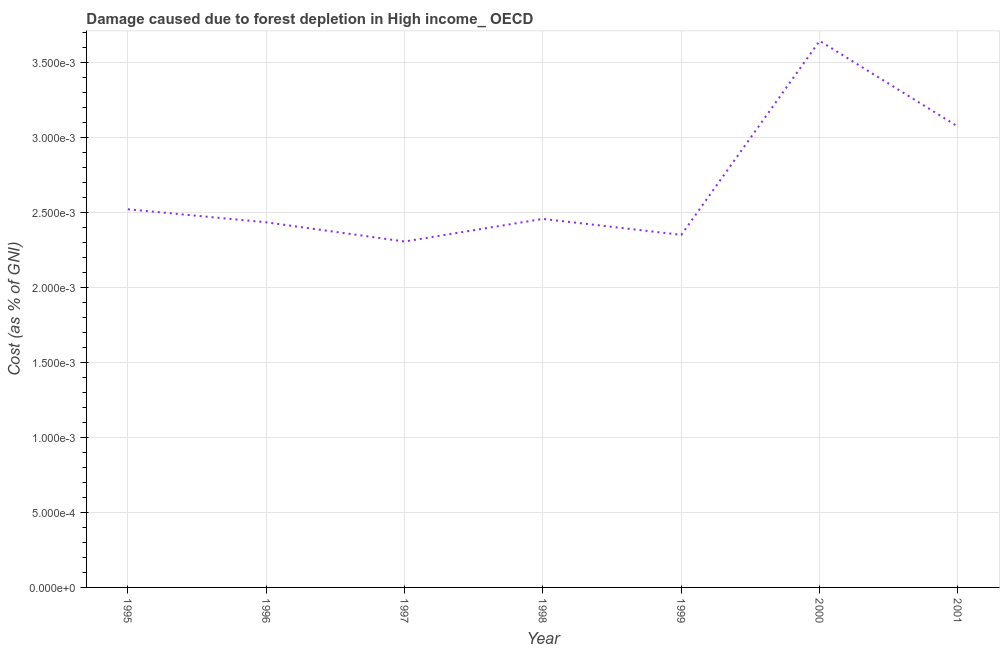What is the damage caused due to forest depletion in 2001?
Keep it short and to the point. 0. Across all years, what is the maximum damage caused due to forest depletion?
Ensure brevity in your answer.  0. Across all years, what is the minimum damage caused due to forest depletion?
Give a very brief answer. 0. In which year was the damage caused due to forest depletion maximum?
Offer a terse response. 2000. In which year was the damage caused due to forest depletion minimum?
Give a very brief answer. 1997. What is the sum of the damage caused due to forest depletion?
Your answer should be compact. 0.02. What is the difference between the damage caused due to forest depletion in 1997 and 1999?
Keep it short and to the point. -4.4440238884519995e-5. What is the average damage caused due to forest depletion per year?
Your answer should be compact. 0. What is the median damage caused due to forest depletion?
Offer a very short reply. 0. What is the ratio of the damage caused due to forest depletion in 1997 to that in 2000?
Ensure brevity in your answer.  0.63. Is the damage caused due to forest depletion in 1999 less than that in 2001?
Provide a short and direct response. Yes. Is the difference between the damage caused due to forest depletion in 1995 and 1997 greater than the difference between any two years?
Provide a short and direct response. No. What is the difference between the highest and the second highest damage caused due to forest depletion?
Your answer should be very brief. 0. Is the sum of the damage caused due to forest depletion in 1996 and 1998 greater than the maximum damage caused due to forest depletion across all years?
Keep it short and to the point. Yes. What is the difference between the highest and the lowest damage caused due to forest depletion?
Your response must be concise. 0. In how many years, is the damage caused due to forest depletion greater than the average damage caused due to forest depletion taken over all years?
Give a very brief answer. 2. What is the difference between two consecutive major ticks on the Y-axis?
Keep it short and to the point. 0. Are the values on the major ticks of Y-axis written in scientific E-notation?
Make the answer very short. Yes. What is the title of the graph?
Give a very brief answer. Damage caused due to forest depletion in High income_ OECD. What is the label or title of the Y-axis?
Your answer should be very brief. Cost (as % of GNI). What is the Cost (as % of GNI) in 1995?
Offer a very short reply. 0. What is the Cost (as % of GNI) in 1996?
Provide a succinct answer. 0. What is the Cost (as % of GNI) of 1997?
Ensure brevity in your answer.  0. What is the Cost (as % of GNI) in 1998?
Your answer should be very brief. 0. What is the Cost (as % of GNI) of 1999?
Make the answer very short. 0. What is the Cost (as % of GNI) of 2000?
Give a very brief answer. 0. What is the Cost (as % of GNI) of 2001?
Provide a succinct answer. 0. What is the difference between the Cost (as % of GNI) in 1995 and 1996?
Your answer should be compact. 9e-5. What is the difference between the Cost (as % of GNI) in 1995 and 1997?
Give a very brief answer. 0. What is the difference between the Cost (as % of GNI) in 1995 and 1998?
Provide a short and direct response. 6e-5. What is the difference between the Cost (as % of GNI) in 1995 and 1999?
Ensure brevity in your answer.  0. What is the difference between the Cost (as % of GNI) in 1995 and 2000?
Your answer should be compact. -0. What is the difference between the Cost (as % of GNI) in 1995 and 2001?
Make the answer very short. -0. What is the difference between the Cost (as % of GNI) in 1996 and 1997?
Make the answer very short. 0. What is the difference between the Cost (as % of GNI) in 1996 and 1998?
Provide a short and direct response. -2e-5. What is the difference between the Cost (as % of GNI) in 1996 and 1999?
Provide a succinct answer. 8e-5. What is the difference between the Cost (as % of GNI) in 1996 and 2000?
Provide a succinct answer. -0. What is the difference between the Cost (as % of GNI) in 1996 and 2001?
Your answer should be compact. -0. What is the difference between the Cost (as % of GNI) in 1997 and 1998?
Provide a succinct answer. -0. What is the difference between the Cost (as % of GNI) in 1997 and 1999?
Your answer should be very brief. -4e-5. What is the difference between the Cost (as % of GNI) in 1997 and 2000?
Offer a terse response. -0. What is the difference between the Cost (as % of GNI) in 1997 and 2001?
Provide a succinct answer. -0. What is the difference between the Cost (as % of GNI) in 1998 and 1999?
Ensure brevity in your answer.  0. What is the difference between the Cost (as % of GNI) in 1998 and 2000?
Offer a very short reply. -0. What is the difference between the Cost (as % of GNI) in 1998 and 2001?
Give a very brief answer. -0. What is the difference between the Cost (as % of GNI) in 1999 and 2000?
Your answer should be very brief. -0. What is the difference between the Cost (as % of GNI) in 1999 and 2001?
Ensure brevity in your answer.  -0. What is the difference between the Cost (as % of GNI) in 2000 and 2001?
Offer a very short reply. 0. What is the ratio of the Cost (as % of GNI) in 1995 to that in 1996?
Offer a very short reply. 1.04. What is the ratio of the Cost (as % of GNI) in 1995 to that in 1997?
Your answer should be very brief. 1.09. What is the ratio of the Cost (as % of GNI) in 1995 to that in 1998?
Give a very brief answer. 1.03. What is the ratio of the Cost (as % of GNI) in 1995 to that in 1999?
Make the answer very short. 1.07. What is the ratio of the Cost (as % of GNI) in 1995 to that in 2000?
Offer a very short reply. 0.69. What is the ratio of the Cost (as % of GNI) in 1995 to that in 2001?
Your response must be concise. 0.82. What is the ratio of the Cost (as % of GNI) in 1996 to that in 1997?
Offer a terse response. 1.06. What is the ratio of the Cost (as % of GNI) in 1996 to that in 1998?
Your response must be concise. 0.99. What is the ratio of the Cost (as % of GNI) in 1996 to that in 1999?
Provide a succinct answer. 1.04. What is the ratio of the Cost (as % of GNI) in 1996 to that in 2000?
Your response must be concise. 0.67. What is the ratio of the Cost (as % of GNI) in 1996 to that in 2001?
Offer a terse response. 0.79. What is the ratio of the Cost (as % of GNI) in 1997 to that in 1998?
Ensure brevity in your answer.  0.94. What is the ratio of the Cost (as % of GNI) in 1997 to that in 2000?
Give a very brief answer. 0.63. What is the ratio of the Cost (as % of GNI) in 1997 to that in 2001?
Ensure brevity in your answer.  0.75. What is the ratio of the Cost (as % of GNI) in 1998 to that in 1999?
Ensure brevity in your answer.  1.04. What is the ratio of the Cost (as % of GNI) in 1998 to that in 2000?
Your response must be concise. 0.67. What is the ratio of the Cost (as % of GNI) in 1998 to that in 2001?
Give a very brief answer. 0.8. What is the ratio of the Cost (as % of GNI) in 1999 to that in 2000?
Ensure brevity in your answer.  0.65. What is the ratio of the Cost (as % of GNI) in 1999 to that in 2001?
Your answer should be very brief. 0.77. What is the ratio of the Cost (as % of GNI) in 2000 to that in 2001?
Offer a terse response. 1.19. 